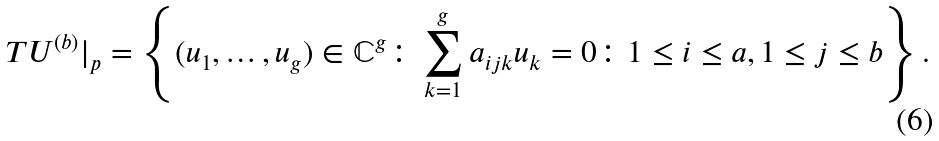Convert formula to latex. <formula><loc_0><loc_0><loc_500><loc_500>T U ^ { ( b ) } | _ { p } = \left \{ ( u _ { 1 } , \dots , u _ { g } ) \in \mathbb { C } ^ { g } \colon \sum _ { k = 1 } ^ { g } a _ { i j k } u _ { k } = 0 \colon 1 \leq i \leq a , 1 \leq j \leq b \right \} .</formula> 